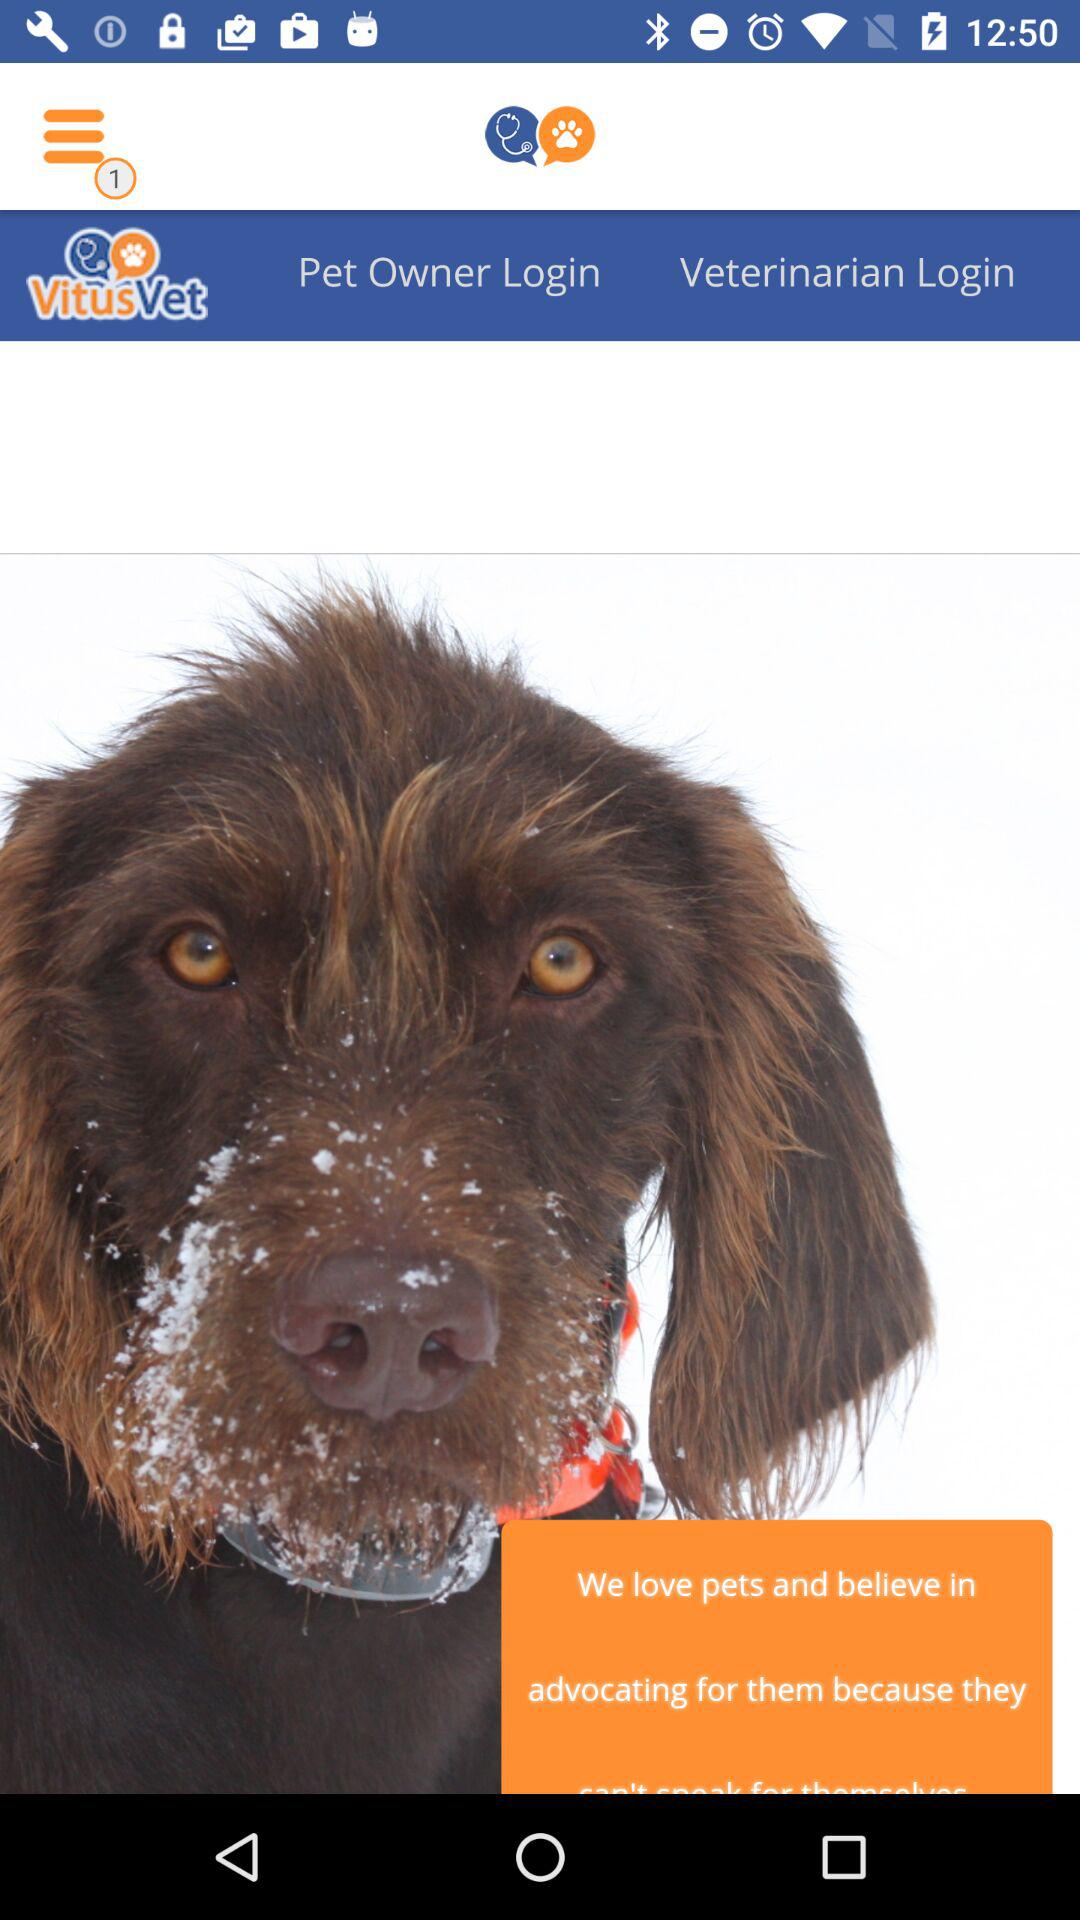What is the name of the application? The name of the application is "VitusVet". 